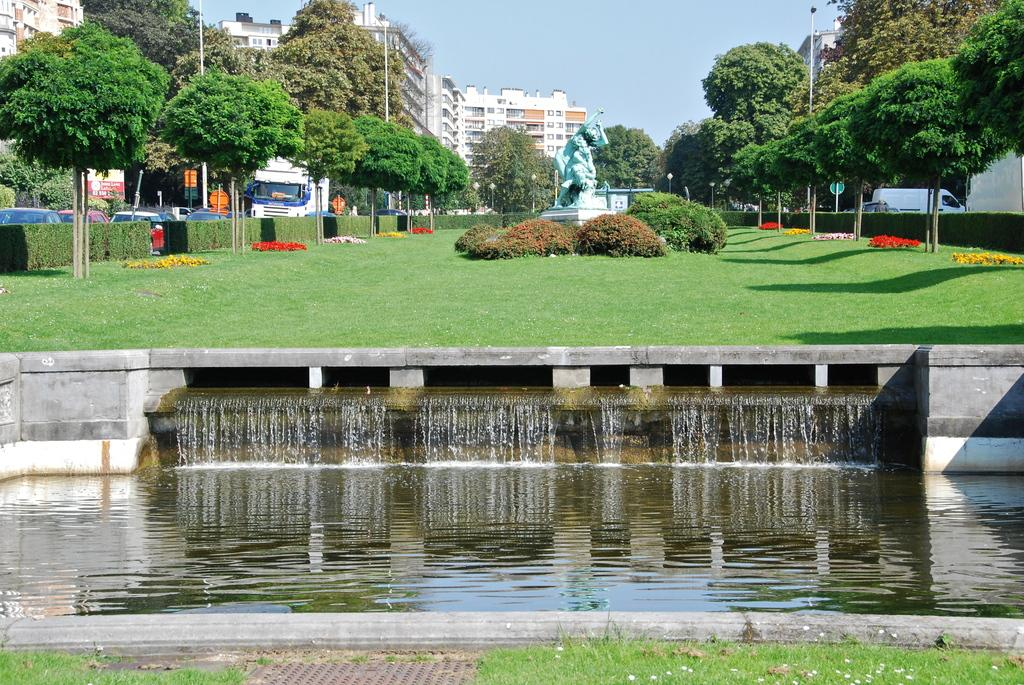What natural element can be seen in the image? Water is visible in the image. What type of vegetation is present in the image? There is grass, trees, plants, and flowers in the image. What man-made objects can be seen in the image? There are vehicles, a sculpture, street lights, and buildings in the image. What is visible at the top of the image? The sky is visible at the top of the image. What type of slope can be seen in the image? There is no slope present in the image. What is the starting point of the journey depicted in the image? There is no journey depicted in the image. 